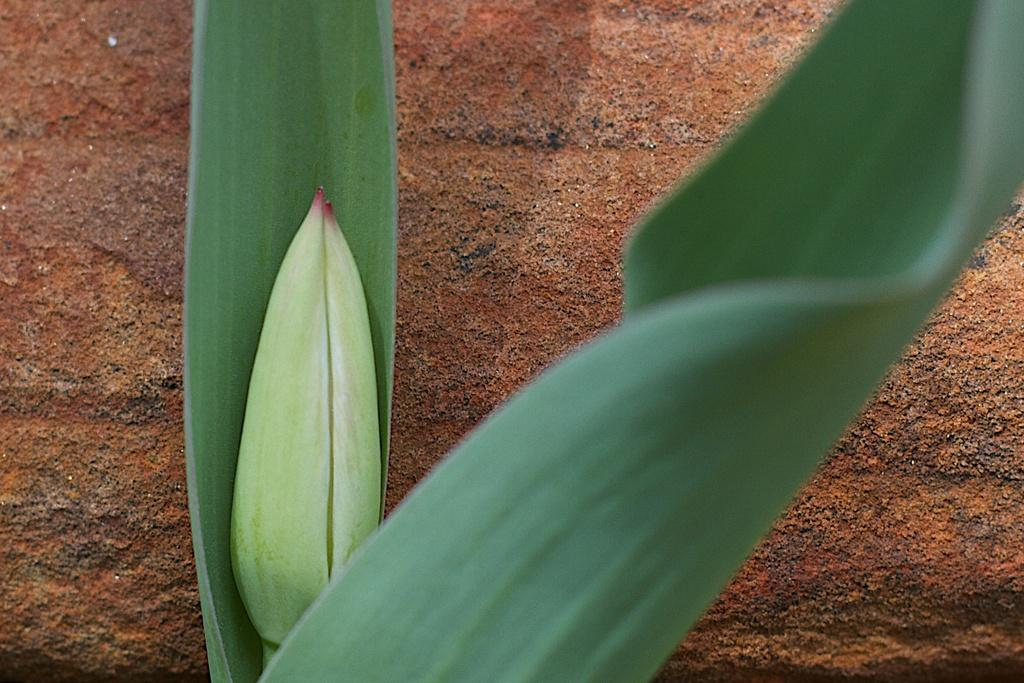What type of vegetation is present in the image? There are leaves in the image. What color are the leaves? The leaves are green in color. What is the color of the background in the image? The background of the image is brown in color. Where is the throne located in the image? There is no throne present in the image. What type of car can be seen driving through the leaves in the image? There is no car present in the image, and the leaves are not depicted as being driven through by any vehicle. 